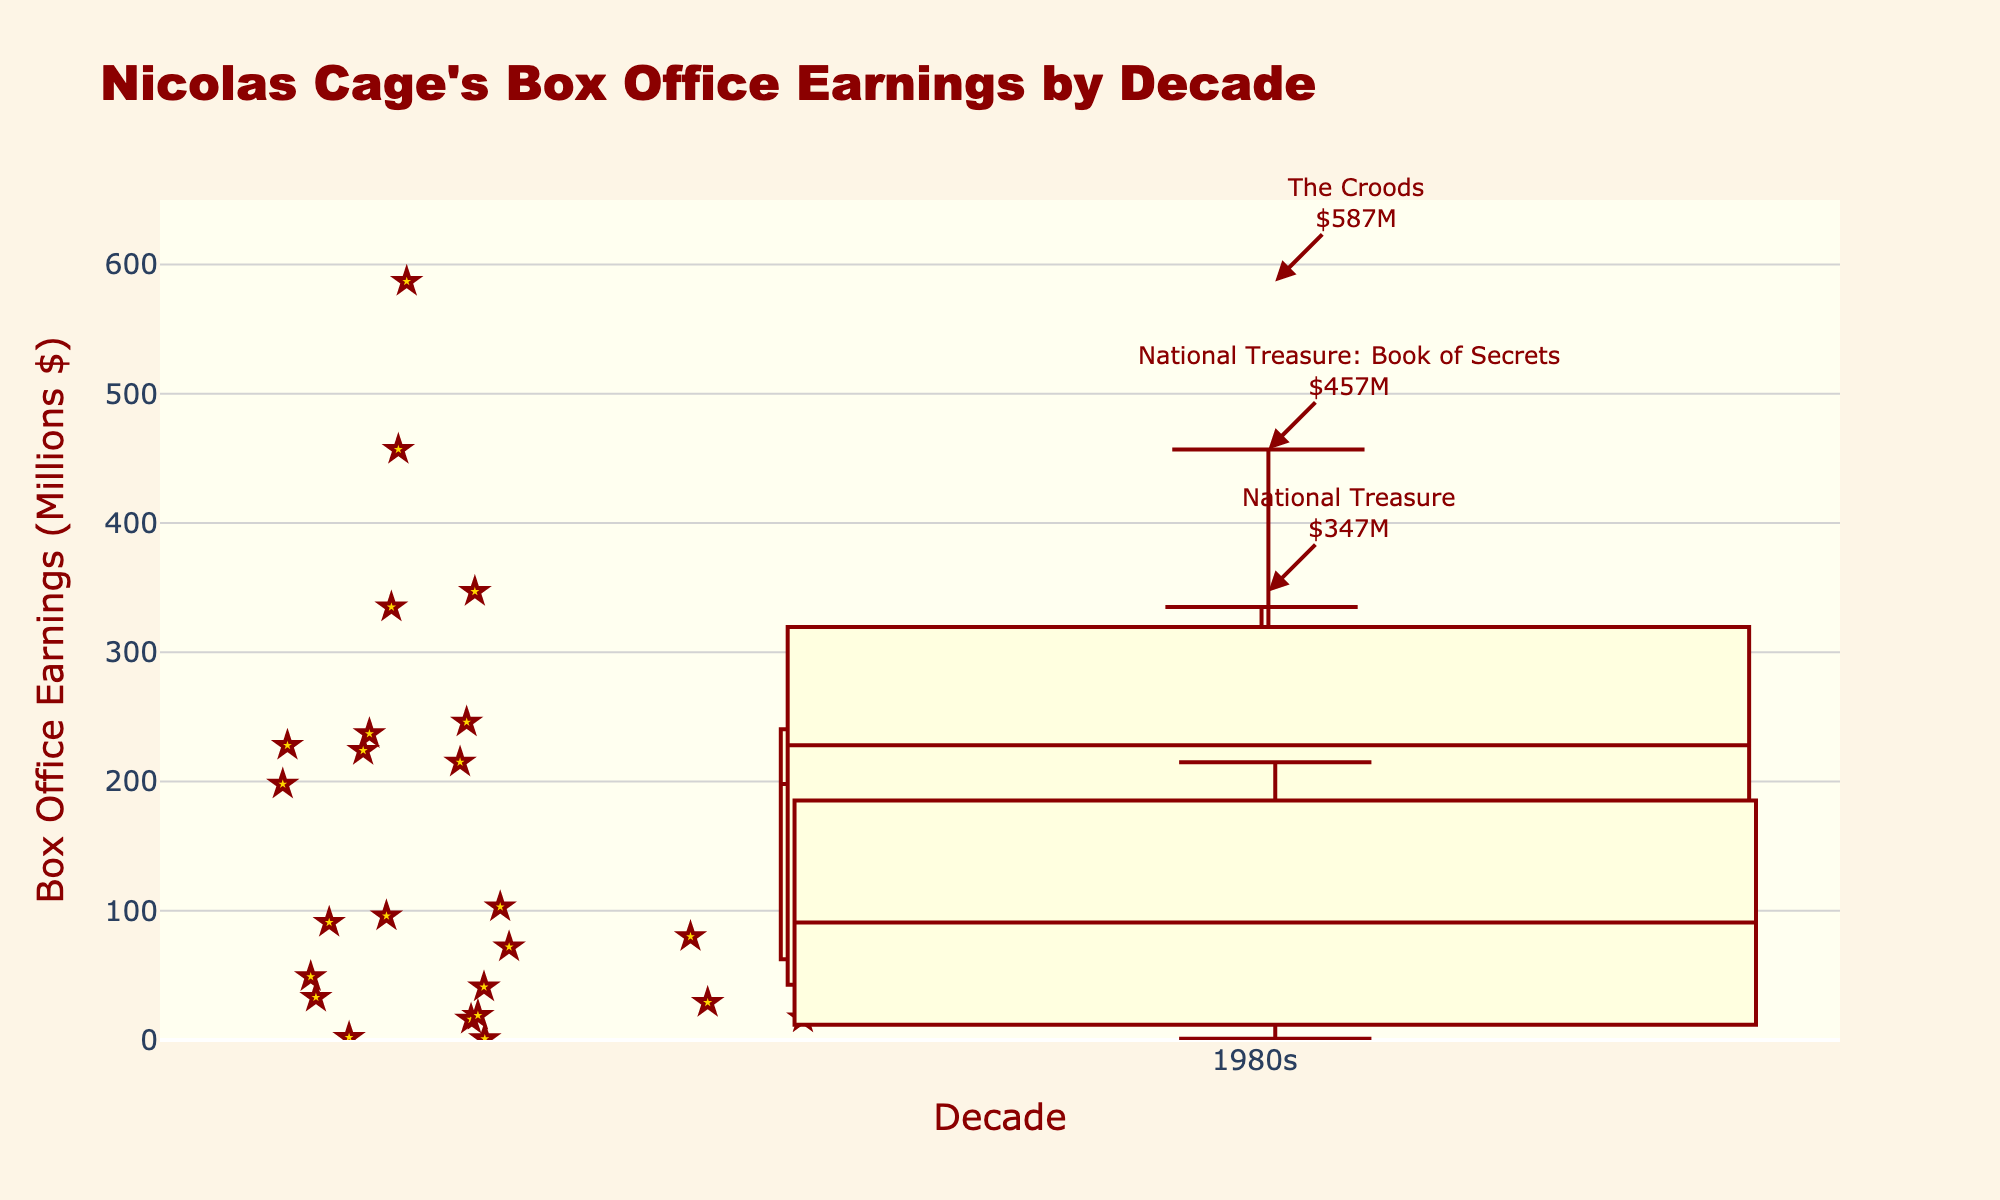What is the title of this plot? The title of the plot appears at the top and provides an overview of what the plot represents. By reading the title, it can be seen that it is "Nicolas Cage's Box Office Earnings by Decade."
Answer: Nicolas Cage's Box Office Earnings by Decade Which decade has the widest box in the plot? The width of the box represents the number of movies in that decade. The widest box indicates the decade with the most movies. From the plot, the 1990s box is the widest.
Answer: 1990s What is the highest box office earnings shown and for which movie? By looking at the highest point in the overall plot, we find "The Croods" from the 2010s with earnings of 587 million dollars.
Answer: The Croods, 587 million dollars How many movies are represented in the 2000s? The width of each box varies according to the number of movies. The 2000s had a reasonably wide box, meaning multiple movies. Counting to verify, the movies are: National Treasure, National Treasure: Book of Secrets, Gone in 60 Seconds, Lord of War, Adaptation, Ghost Rider, and The Weather Man, totaling 7 movies.
Answer: 7 Which decade has the lowest median box office earnings, and what is the value? The median is indicated by the line inside the box. The 1980s box shows the lowest median around the 30-40 million range.
Answer: 1980s, approximately 40 million dollars In which decade did Nicolas Cage have movies with earnings under 10 million dollars, and what are these movies? Look for the points below 10 million earnings in the plot. The movies are found in the 2010s: "Joe" and "Dying of the Light" with earnings of 2 and 1 million dollars respectively.
Answer: 2010s, Joe and Dying of the Light Which movie appears to have the closest box office earnings to the median of the 1990s? The median line in the 1990s box appears around the 150-200 million range. From the data, "City of Angels" with 198 million dollars is closest to this median.
Answer: City of Angels What is the range of earnings for the 2000s? The range is defined by the difference between the highest and lowest points (whiskers) of the box. For the 2000s, the highest is National Treasure: Book of Secrets at 457 million and the lowest is The Weather Man at 19 million. The range is calculated as 457 - 19 = 438 million dollars.
Answer: 438 million dollars How does the interquartile range (IQR) of the 1980s compare with that of the 2010s? The IQR is the distance between the first quartile (bottom of the box) and the third quartile (top of the box). Visually inspecting the boxes, the IQR for the 1980s is smaller than that for the 2010s, indicating less variance in the middle 50% of the earnings.
Answer: The IQR of the 1980s is smaller compared to the 2010s Which decade had the most varied box office performance? The most varied performance can be assessed by looking at the interquartile range (box height) and the total range (distance between whiskers). The 2000s show a broad maximum-minimum spread, along with a substantial interquartile range, indicating significant variability.
Answer: 2000s 